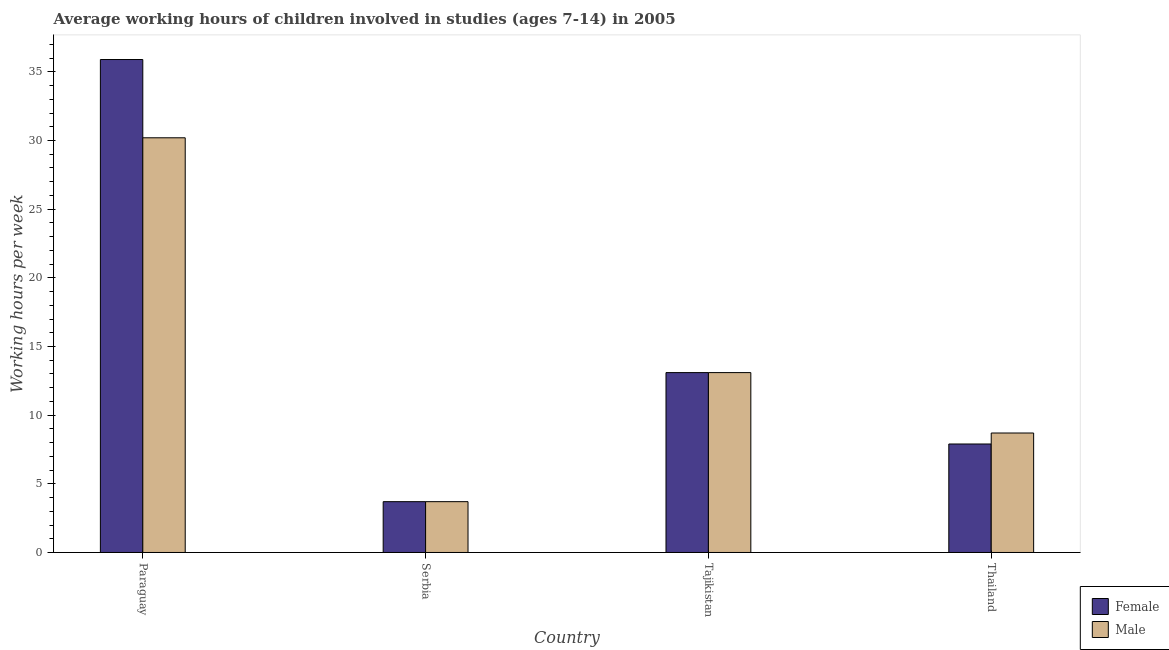How many bars are there on the 2nd tick from the left?
Offer a very short reply. 2. What is the label of the 3rd group of bars from the left?
Offer a very short reply. Tajikistan. What is the average working hour of female children in Paraguay?
Offer a very short reply. 35.9. Across all countries, what is the maximum average working hour of female children?
Your response must be concise. 35.9. Across all countries, what is the minimum average working hour of female children?
Provide a short and direct response. 3.7. In which country was the average working hour of male children maximum?
Ensure brevity in your answer.  Paraguay. In which country was the average working hour of male children minimum?
Give a very brief answer. Serbia. What is the total average working hour of female children in the graph?
Offer a very short reply. 60.6. What is the difference between the average working hour of female children in Paraguay and that in Serbia?
Provide a short and direct response. 32.2. What is the average average working hour of female children per country?
Offer a very short reply. 15.15. What is the difference between the average working hour of female children and average working hour of male children in Serbia?
Your response must be concise. 0. What is the ratio of the average working hour of female children in Serbia to that in Thailand?
Provide a short and direct response. 0.47. Is the average working hour of female children in Paraguay less than that in Thailand?
Give a very brief answer. No. Is the difference between the average working hour of female children in Paraguay and Serbia greater than the difference between the average working hour of male children in Paraguay and Serbia?
Your response must be concise. Yes. What is the difference between the highest and the second highest average working hour of female children?
Your answer should be very brief. 22.8. What is the difference between the highest and the lowest average working hour of female children?
Offer a terse response. 32.2. In how many countries, is the average working hour of male children greater than the average average working hour of male children taken over all countries?
Offer a terse response. 1. What does the 1st bar from the left in Serbia represents?
Your answer should be very brief. Female. How many bars are there?
Offer a very short reply. 8. What is the difference between two consecutive major ticks on the Y-axis?
Your answer should be compact. 5. Are the values on the major ticks of Y-axis written in scientific E-notation?
Keep it short and to the point. No. Where does the legend appear in the graph?
Ensure brevity in your answer.  Bottom right. How many legend labels are there?
Make the answer very short. 2. How are the legend labels stacked?
Provide a succinct answer. Vertical. What is the title of the graph?
Provide a succinct answer. Average working hours of children involved in studies (ages 7-14) in 2005. What is the label or title of the X-axis?
Make the answer very short. Country. What is the label or title of the Y-axis?
Provide a short and direct response. Working hours per week. What is the Working hours per week in Female in Paraguay?
Offer a terse response. 35.9. What is the Working hours per week of Male in Paraguay?
Your answer should be very brief. 30.2. What is the Working hours per week of Female in Serbia?
Provide a short and direct response. 3.7. What is the Working hours per week of Male in Serbia?
Make the answer very short. 3.7. What is the Working hours per week in Male in Thailand?
Your response must be concise. 8.7. Across all countries, what is the maximum Working hours per week of Female?
Provide a succinct answer. 35.9. Across all countries, what is the maximum Working hours per week in Male?
Provide a succinct answer. 30.2. Across all countries, what is the minimum Working hours per week in Male?
Provide a short and direct response. 3.7. What is the total Working hours per week in Female in the graph?
Keep it short and to the point. 60.6. What is the total Working hours per week in Male in the graph?
Offer a terse response. 55.7. What is the difference between the Working hours per week in Female in Paraguay and that in Serbia?
Your response must be concise. 32.2. What is the difference between the Working hours per week in Female in Paraguay and that in Tajikistan?
Offer a very short reply. 22.8. What is the difference between the Working hours per week of Male in Paraguay and that in Thailand?
Your answer should be compact. 21.5. What is the difference between the Working hours per week in Female in Serbia and that in Tajikistan?
Provide a short and direct response. -9.4. What is the difference between the Working hours per week of Male in Serbia and that in Tajikistan?
Offer a very short reply. -9.4. What is the difference between the Working hours per week in Female in Serbia and that in Thailand?
Offer a very short reply. -4.2. What is the difference between the Working hours per week of Male in Serbia and that in Thailand?
Keep it short and to the point. -5. What is the difference between the Working hours per week in Female in Tajikistan and that in Thailand?
Make the answer very short. 5.2. What is the difference between the Working hours per week in Male in Tajikistan and that in Thailand?
Your answer should be very brief. 4.4. What is the difference between the Working hours per week in Female in Paraguay and the Working hours per week in Male in Serbia?
Keep it short and to the point. 32.2. What is the difference between the Working hours per week of Female in Paraguay and the Working hours per week of Male in Tajikistan?
Provide a short and direct response. 22.8. What is the difference between the Working hours per week in Female in Paraguay and the Working hours per week in Male in Thailand?
Ensure brevity in your answer.  27.2. What is the average Working hours per week of Female per country?
Provide a succinct answer. 15.15. What is the average Working hours per week of Male per country?
Offer a very short reply. 13.93. What is the difference between the Working hours per week in Female and Working hours per week in Male in Serbia?
Give a very brief answer. 0. What is the difference between the Working hours per week in Female and Working hours per week in Male in Tajikistan?
Provide a succinct answer. 0. What is the difference between the Working hours per week in Female and Working hours per week in Male in Thailand?
Offer a terse response. -0.8. What is the ratio of the Working hours per week in Female in Paraguay to that in Serbia?
Your response must be concise. 9.7. What is the ratio of the Working hours per week of Male in Paraguay to that in Serbia?
Your answer should be compact. 8.16. What is the ratio of the Working hours per week in Female in Paraguay to that in Tajikistan?
Your response must be concise. 2.74. What is the ratio of the Working hours per week of Male in Paraguay to that in Tajikistan?
Offer a terse response. 2.31. What is the ratio of the Working hours per week in Female in Paraguay to that in Thailand?
Your answer should be compact. 4.54. What is the ratio of the Working hours per week in Male in Paraguay to that in Thailand?
Give a very brief answer. 3.47. What is the ratio of the Working hours per week of Female in Serbia to that in Tajikistan?
Keep it short and to the point. 0.28. What is the ratio of the Working hours per week in Male in Serbia to that in Tajikistan?
Ensure brevity in your answer.  0.28. What is the ratio of the Working hours per week of Female in Serbia to that in Thailand?
Give a very brief answer. 0.47. What is the ratio of the Working hours per week in Male in Serbia to that in Thailand?
Provide a short and direct response. 0.43. What is the ratio of the Working hours per week in Female in Tajikistan to that in Thailand?
Offer a very short reply. 1.66. What is the ratio of the Working hours per week of Male in Tajikistan to that in Thailand?
Offer a terse response. 1.51. What is the difference between the highest and the second highest Working hours per week of Female?
Your response must be concise. 22.8. What is the difference between the highest and the second highest Working hours per week of Male?
Your response must be concise. 17.1. What is the difference between the highest and the lowest Working hours per week of Female?
Your answer should be compact. 32.2. 